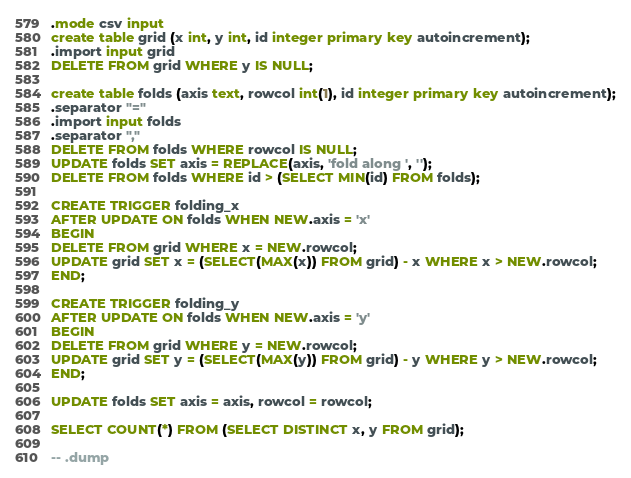Convert code to text. <code><loc_0><loc_0><loc_500><loc_500><_SQL_>.mode csv input
create table grid (x int, y int, id integer primary key autoincrement);
.import input grid
DELETE FROM grid WHERE y IS NULL;

create table folds (axis text, rowcol int(1), id integer primary key autoincrement);
.separator "="
.import input folds
.separator ","
DELETE FROM folds WHERE rowcol IS NULL;
UPDATE folds SET axis = REPLACE(axis, 'fold along ', '');
DELETE FROM folds WHERE id > (SELECT MIN(id) FROM folds);

CREATE TRIGGER folding_x
AFTER UPDATE ON folds WHEN NEW.axis = 'x'
BEGIN
DELETE FROM grid WHERE x = NEW.rowcol;
UPDATE grid SET x = (SELECT(MAX(x)) FROM grid) - x WHERE x > NEW.rowcol;
END;

CREATE TRIGGER folding_y
AFTER UPDATE ON folds WHEN NEW.axis = 'y'
BEGIN
DELETE FROM grid WHERE y = NEW.rowcol;
UPDATE grid SET y = (SELECT(MAX(y)) FROM grid) - y WHERE y > NEW.rowcol;
END;

UPDATE folds SET axis = axis, rowcol = rowcol;

SELECT COUNT(*) FROM (SELECT DISTINCT x, y FROM grid);

-- .dump
</code> 